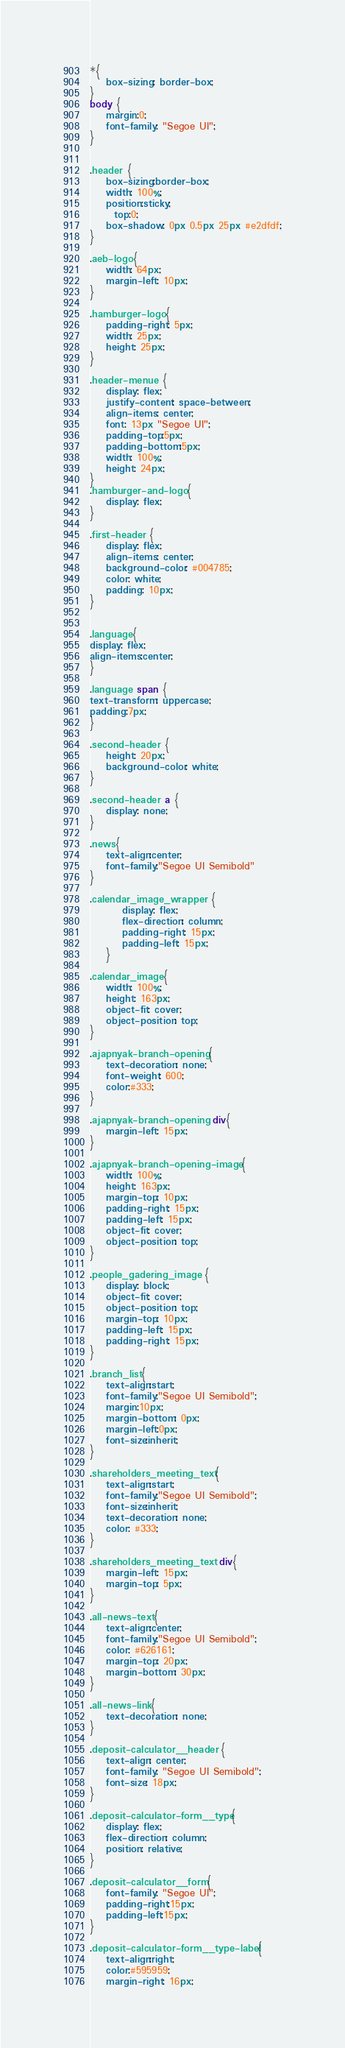Convert code to text. <code><loc_0><loc_0><loc_500><loc_500><_CSS_>*{
    box-sizing: border-box;
}
body {
    margin:0;
    font-family: "Segoe UI";
}


.header {
    box-sizing:border-box;
    width: 100%;
    position:sticky;
      top:0;
    box-shadow: 0px 0.5px 25px #e2dfdf;
}

.aeb-logo{
    width: 64px;
    margin-left: 10px;
}

.hamburger-logo{
    padding-right: 5px;
    width: 25px;
    height: 25px;
}

.header-menue {
    display: flex;
    justify-content: space-between;
    align-items: center;
    font: 13px "Segoe UI";
    padding-top:5px;
    padding-bottom:5px;
    width: 100%;
    height: 24px;
}
.hamburger-and-logo{
    display: flex;
}

.first-header {
    display: flex;
    align-items: center;
    background-color: #004785;
    color: white;
    padding: 10px;  
}


.language{
display: flex;
align-items:center;
}

.language span {
text-transform: uppercase;
padding:7px;
}

.second-header {
    height: 20px;
    background-color: white;
}

.second-header a {
    display: none;
}

.news{
    text-align:center;
    font-family:"Segoe UI Semibold"
}

.calendar_image_wrapper {
        display: flex;
        flex-direction: column;
        padding-right: 15px;
        padding-left: 15px;
    }

.calendar_image{
    width: 100%;
    height: 163px;
    object-fit: cover;
    object-position: top;
}

.ajapnyak-branch-opening{
    text-decoration: none;
    font-weight: 600;
    color:#333; 
}

.ajapnyak-branch-opening div{
    margin-left: 15px;
}

.ajapnyak-branch-opening-image{
    width: 100%;
    height: 163px;
    margin-top: 10px;
    padding-right: 15px;
    padding-left: 15px;
    object-fit: cover;
    object-position: top;
}

.people_gadering_image {
    display: block;
    object-fit: cover;
    object-position: top;
    margin-top: 10px;
    padding-left: 15px;
    padding-right: 15px;
}

.branch_list{
    text-align:start;
    font-family:"Segoe UI Semibold";
    margin:10px;
    margin-bottom: 0px;
    margin-left:0px;
    font-size:inherit;
}

.shareholders_meeting_text{
    text-align:start;
    font-family:"Segoe UI Semibold";
    font-size:inherit;
    text-decoration: none;
    color: #333;
}

.shareholders_meeting_text div{
    margin-left: 15px;
    margin-top: 5px;
}

.all-news-text{
    text-align:center;
    font-family:"Segoe UI Semibold";
    color: #626161;
    margin-top: 20px;
    margin-bottom: 30px;
}

.all-news-link{
    text-decoration: none;
}

.deposit-calculator__header {
    text-align: center;
    font-family: "Segoe UI Semibold";
    font-size: 18px;
}

.deposit-calculator-form__type{
    display: flex;
    flex-direction: column;
    position: relative;
}

.deposit-calculator__form{
    font-family: "Segoe UI";
    padding-right:15px;
    padding-left:15px;
}

.deposit-calculator-form__type-label{
    text-align:right;
    color:#595959;
    margin-right: 16px;</code> 